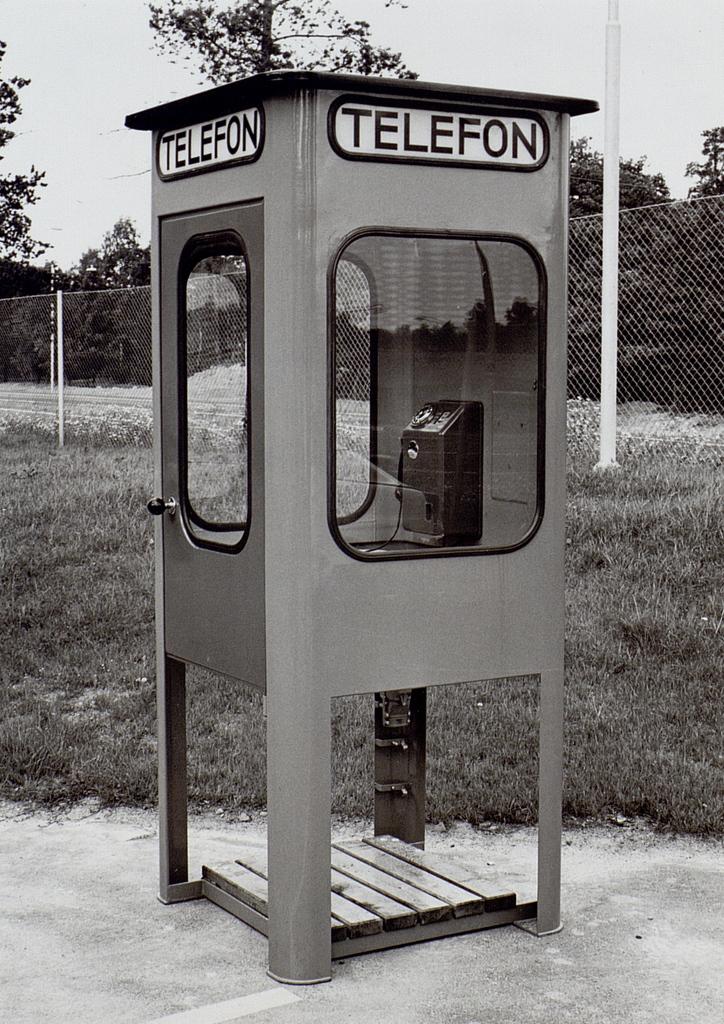What is located inside this?
Keep it short and to the point. Telefon. What is the word on top of the box?
Give a very brief answer. Telefon. 